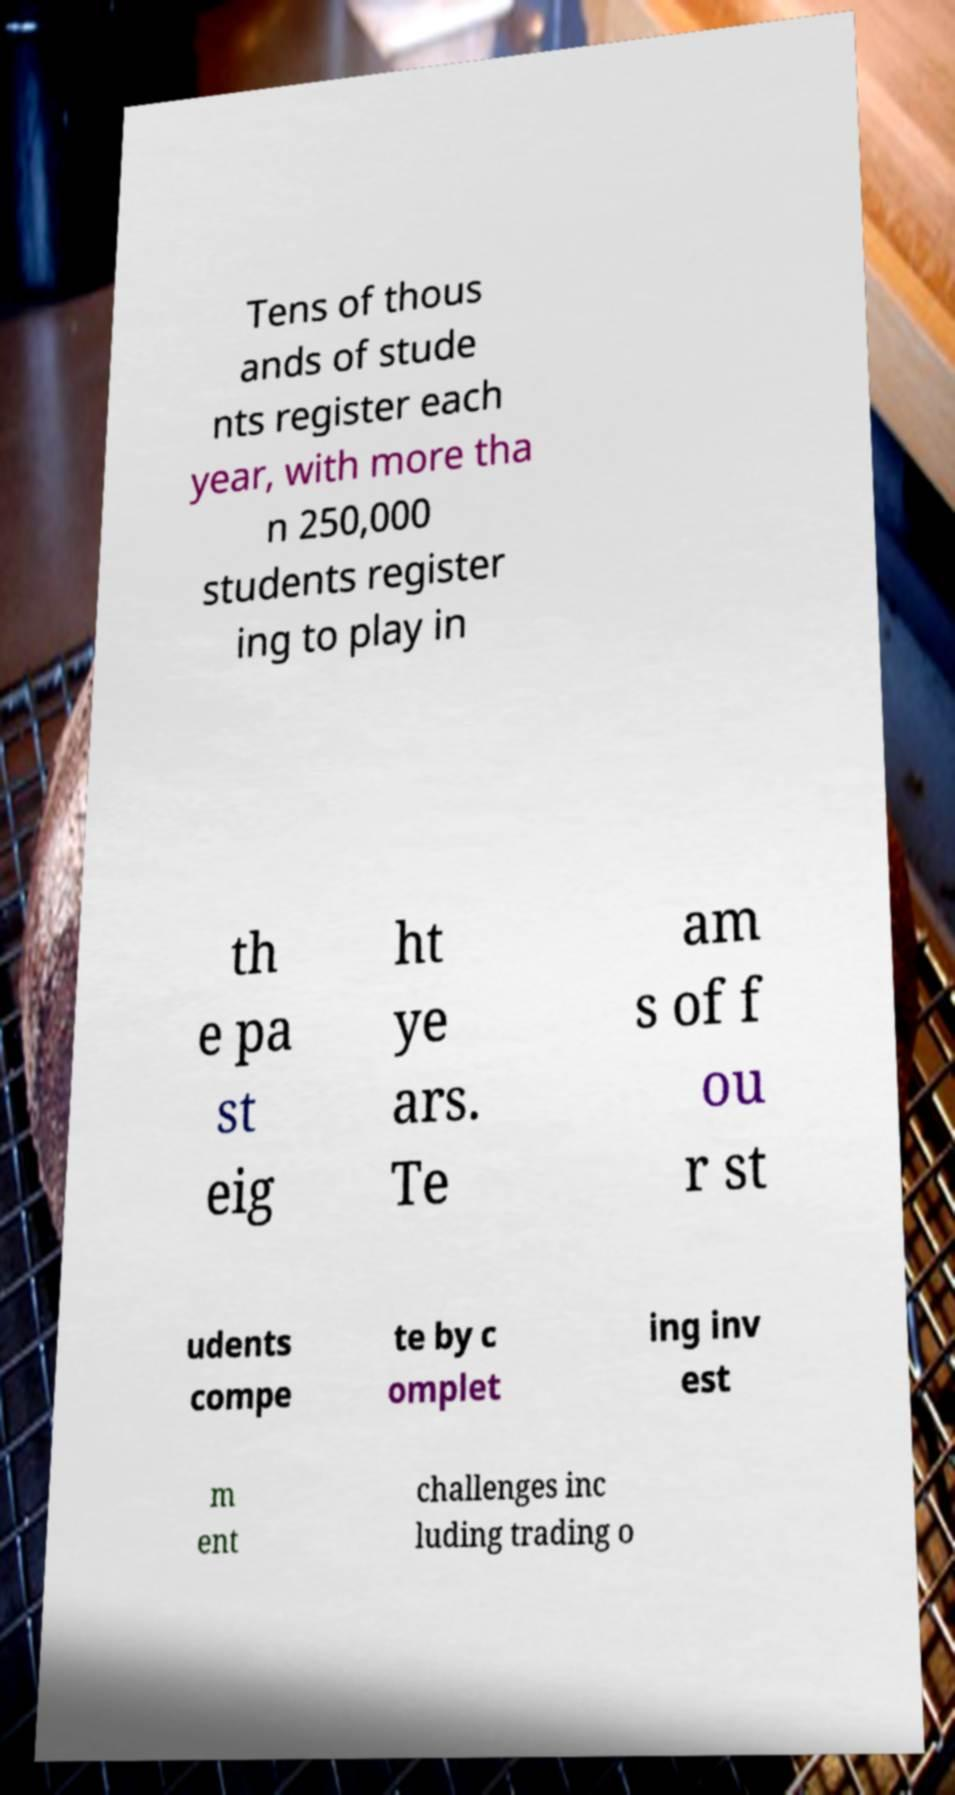For documentation purposes, I need the text within this image transcribed. Could you provide that? Tens of thous ands of stude nts register each year, with more tha n 250,000 students register ing to play in th e pa st eig ht ye ars. Te am s of f ou r st udents compe te by c omplet ing inv est m ent challenges inc luding trading o 